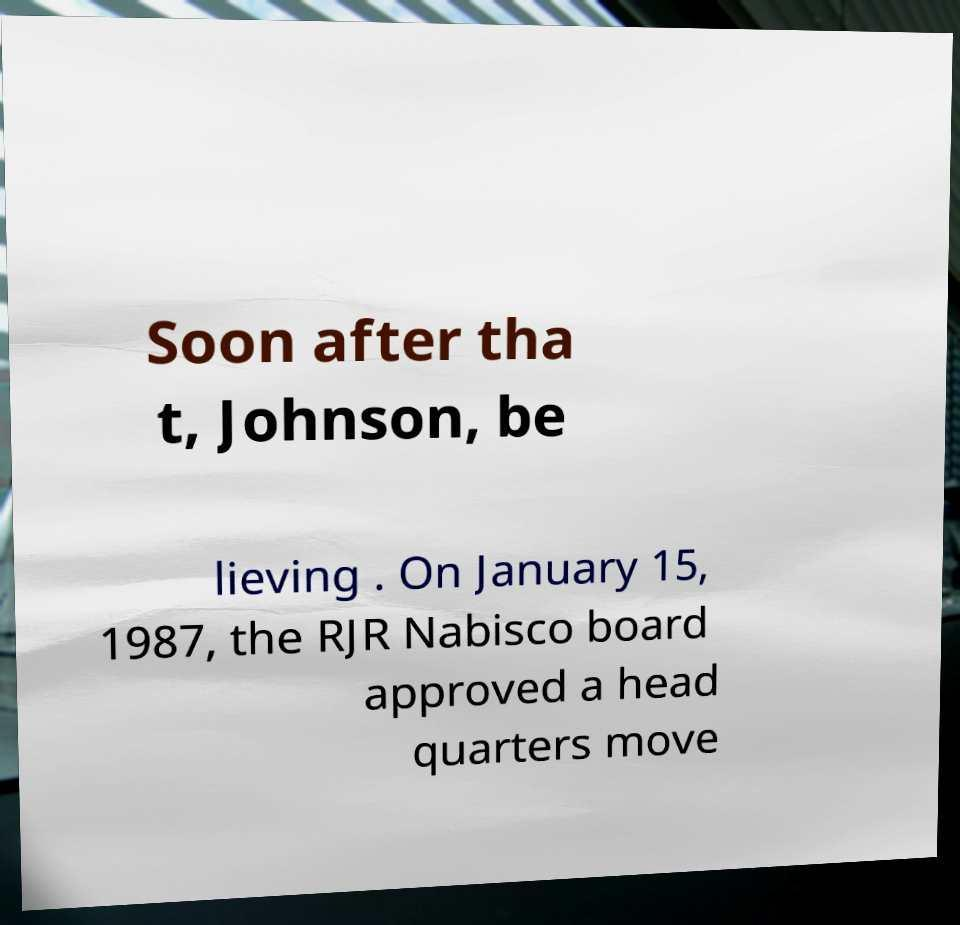I need the written content from this picture converted into text. Can you do that? Soon after tha t, Johnson, be lieving . On January 15, 1987, the RJR Nabisco board approved a head quarters move 